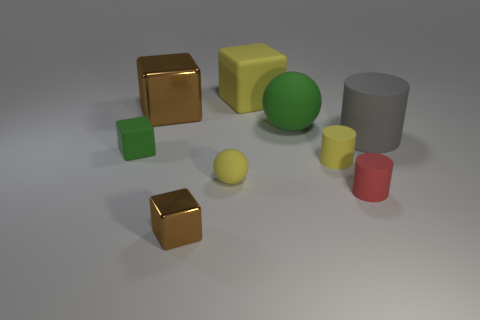Subtract all red rubber cylinders. How many cylinders are left? 2 Subtract 4 cubes. How many cubes are left? 0 Subtract all red cylinders. How many cylinders are left? 2 Subtract all cylinders. How many objects are left? 6 Subtract all gray balls. Subtract all purple blocks. How many balls are left? 2 Subtract all red cylinders. How many green cubes are left? 1 Subtract all large metal things. Subtract all gray rubber things. How many objects are left? 7 Add 6 big brown shiny objects. How many big brown shiny objects are left? 7 Add 6 small yellow rubber spheres. How many small yellow rubber spheres exist? 7 Subtract 0 gray spheres. How many objects are left? 9 